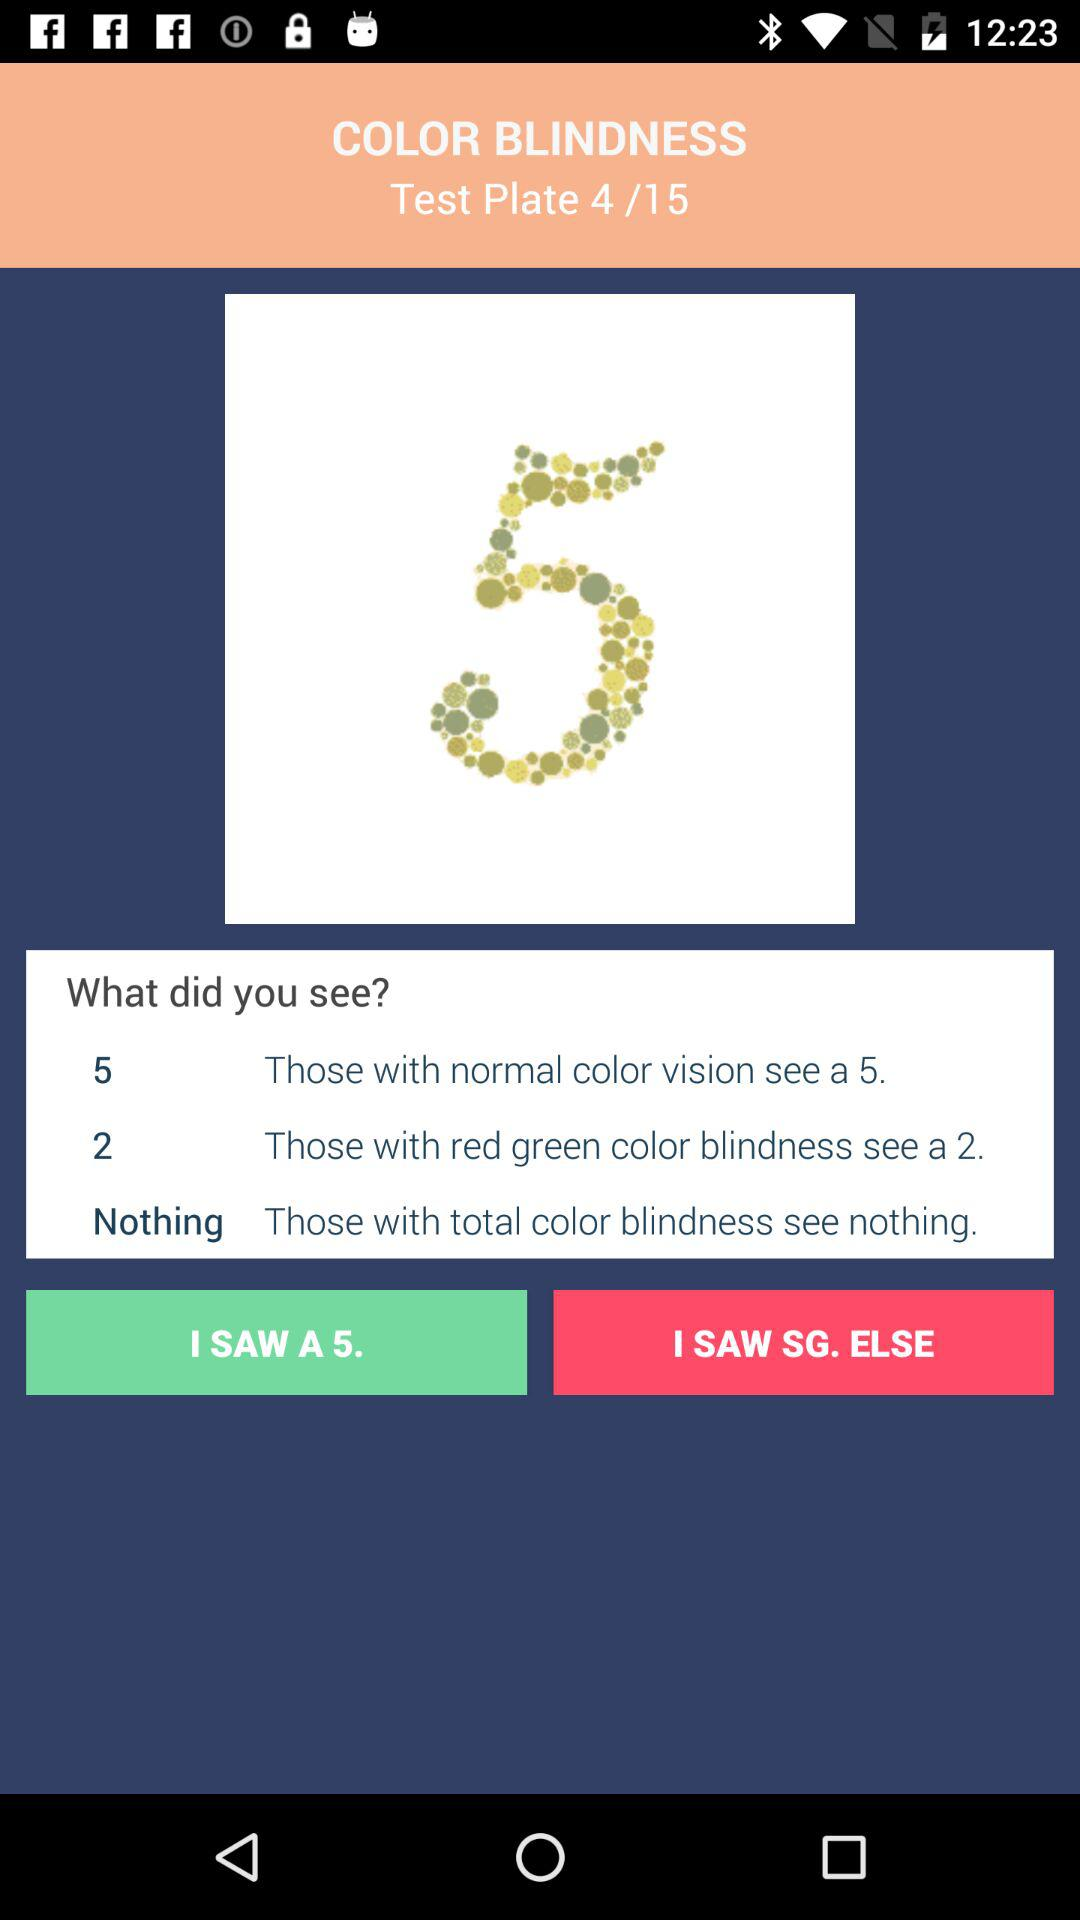What do people with normal color vision see on the plate? People with normal color vision see a 5 on the plate. 